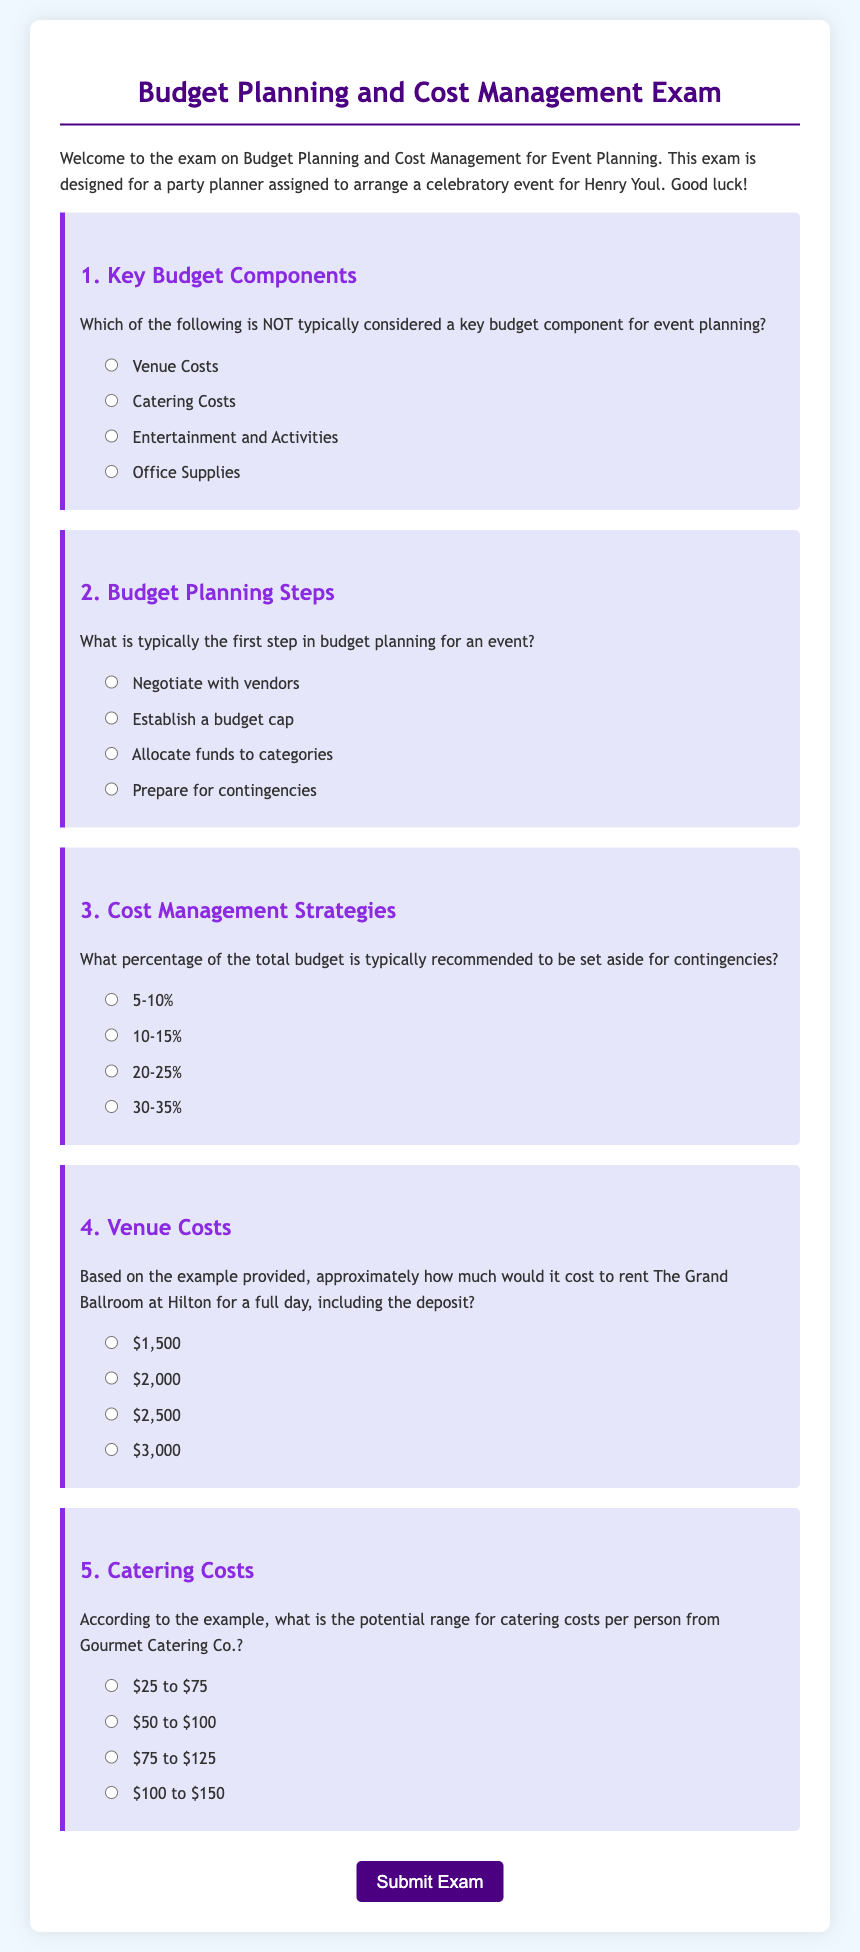What is the document's title? The title of the document is stated in the head section and is "Budget Planning and Cost Management Exam."
Answer: Budget Planning and Cost Management Exam Who is the exam intended for? The introduction states that the exam is designed for a party planner assigned to arrange a celebratory event for Henry Youl.
Answer: Henry Youl What are the key budget components mentioned? The document lists venue costs, catering costs, entertainment, and activities, with office supplies identified as NOT a key component.
Answer: Office Supplies What is the recommended contingency percentage? The exam contains a question indicating that typically 5-10% of the total budget is recommended to be set aside for contingencies.
Answer: 5-10% According to the document, how much is the approximate cost to rent The Grand Ballroom at Hilton for a full day? The document provides options for the cost, with one of the options being $2,000 for the rental of The Grand Ballroom including the deposit.
Answer: $2,000 What is the potential range for catering costs per person? The document specifies that the potential range for catering costs from Gourmet Catering Co. is $25 to $75 per person.
Answer: $25 to $75 